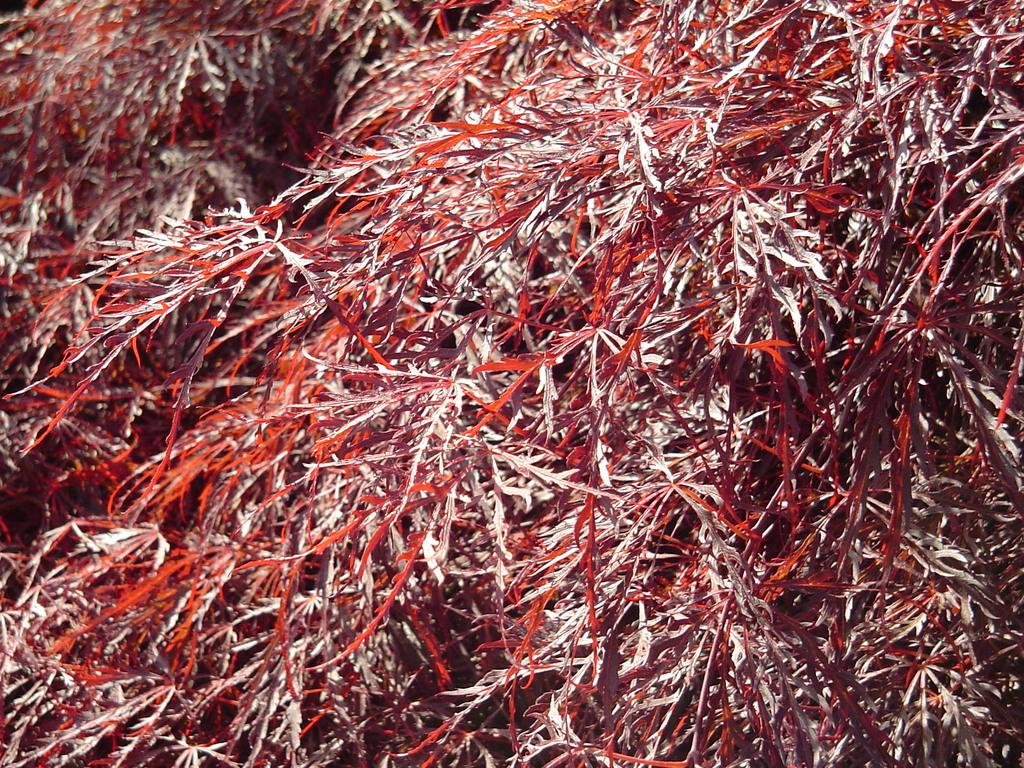What type of vegetation can be seen in the image? There is grass in the image. What is the price of the blade in the image? There is no blade present in the image, and therefore no price can be determined. 